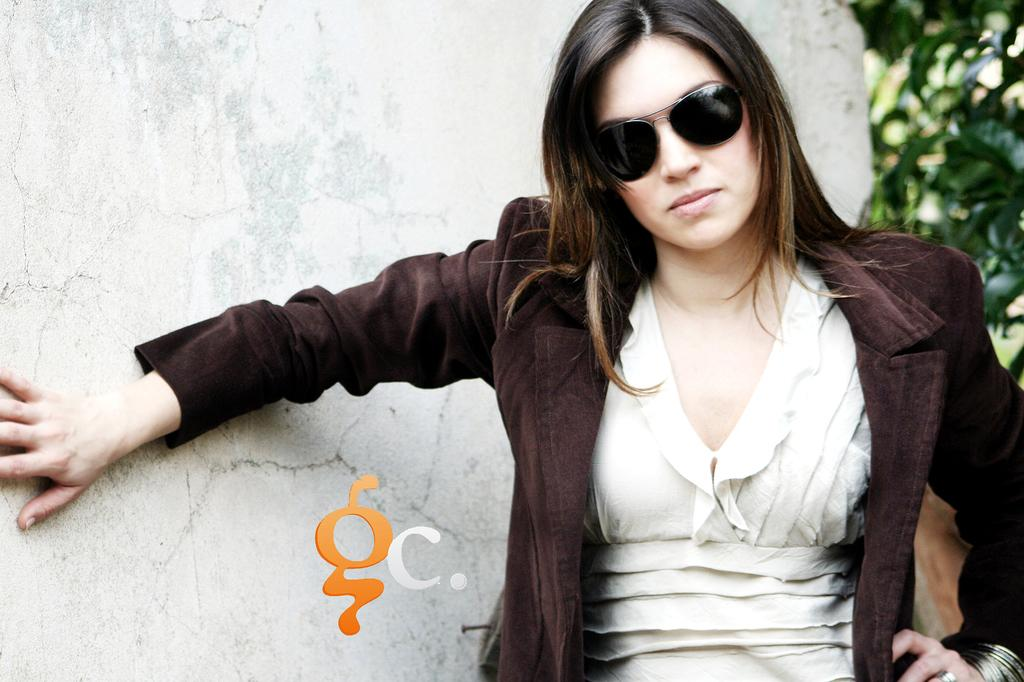Who or what is in the image? There is a person in the image. What is the person doing or standing in front of? The person is standing in front of a wall. What can be observed about the person's attire? The person is wearing clothes. What accessory is the person wearing on their face? The person is wearing sunglasses. What additional information is provided at the bottom of the image? There is text at the bottom of the image. What type of operation is the person undergoing in the image? There is no indication of an operation in the image; the person is simply standing in front of a wall. How does the person's digestion system appear in the image? There is no visible information about the person's digestion system in the image. 